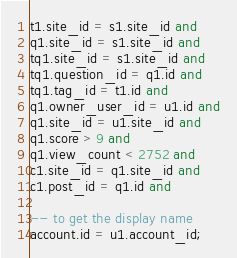<code> <loc_0><loc_0><loc_500><loc_500><_SQL_>t1.site_id = s1.site_id and
q1.site_id = s1.site_id and
tq1.site_id = s1.site_id and
tq1.question_id = q1.id and
tq1.tag_id = t1.id and
q1.owner_user_id = u1.id and
q1.site_id = u1.site_id and
q1.score > 9 and
q1.view_count < 2752 and
c1.site_id = q1.site_id and
c1.post_id = q1.id and

-- to get the display name
account.id = u1.account_id;

</code> 